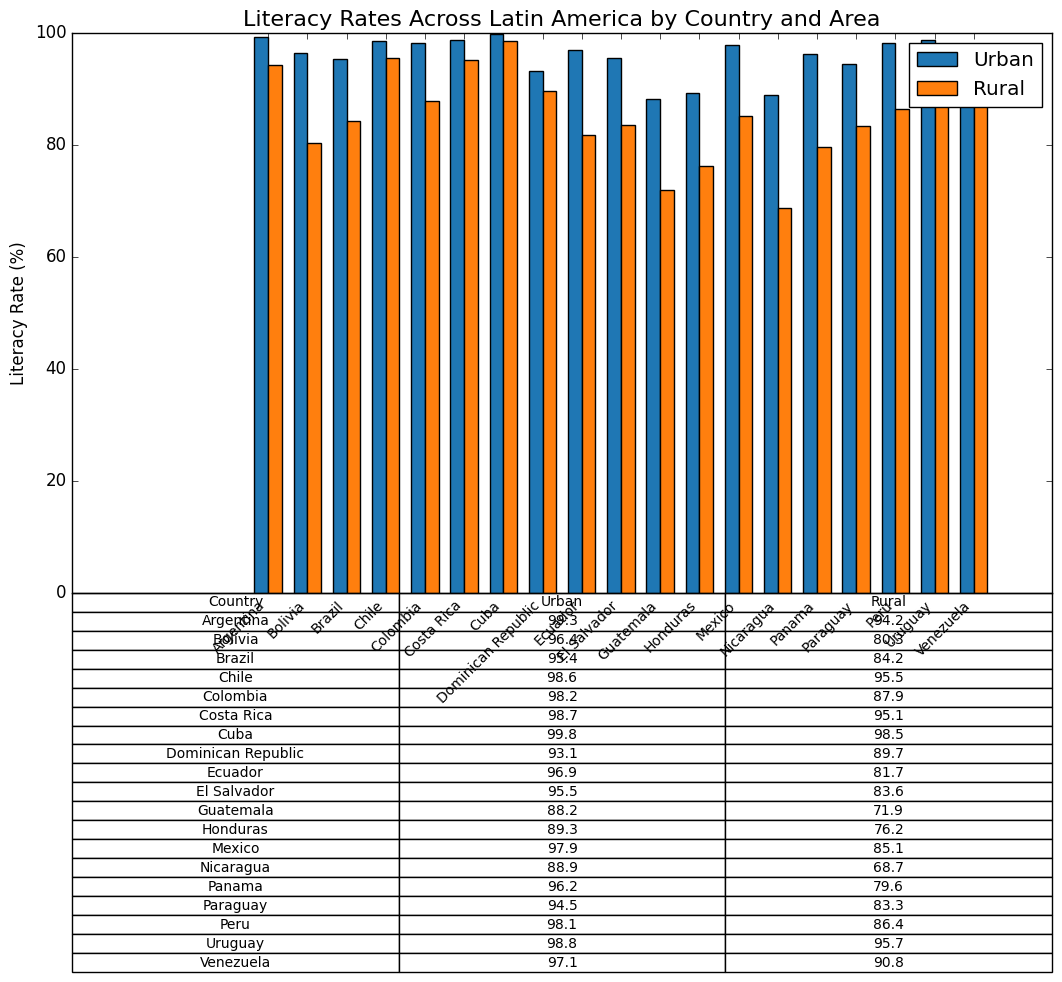What's the country with the highest rural literacy rate? Cuba has the highest rural literacy rate at 98.5%. This can be determined by looking at the values in the table under the "Rural" column or the height of the orange bars in the plot for rural areas.
Answer: Cuba Which country has a smaller gap between urban and rural literacy rates: Paraguay or Brazil? The gap is calculated by subtracting the rural literacy rate from the urban literacy rate for each country. For Paraguay, it's 94.5 - 83.3 = 11.2 percentage points. For Brazil, it's 95.4 - 84.2 = 11.2 percentage points. Thus, both countries have the same gap between urban and rural literacy rates.
Answer: Both have the same gap Which country has the largest difference in literacy rates between urban and rural areas? To find the largest difference, subtract the rural literacy rate from the urban literacy rate for each country and compare the results. The largest difference is for Guatemala: 88.2 (Urban) - 71.9 (Rural) = 16.3 percentage points.
Answer: Guatemala What is the average urban literacy rate across all the countries? To calculate the average urban literacy rate, sum the urban literacy rates and divide by the number of countries: (99.3 + 96.4 + 95.4 + 98.6 + 98.2 + 98.7 + 99.8 + 93.1 + 96.9 + 95.5 + 88.2 + 89.3 + 97.9 + 88.9 + 96.2 + 94.5 + 98.1 + 98.8 + 97.1) / 19 = 96.10%.
Answer: 96.10% Which two countries have the closest urban literacy rates? By comparing the urban literacy rates for all countries, the closest rates are for Colombia (98.2) and Peru (98.1), with a difference of 0.1 percentage points.
Answer: Colombia and Peru Which country's rural literacy rate is closest to 80%? Looking at the "Rural" column in the table, Bolivia has a rural literacy rate of 80.3%, which is the closest to 80%.
Answer: Bolivia What's the average rural literacy rate for countries where the urban literacy rate is greater than 98%? First, identify countries where the urban literacy rate is greater than 98%: Argentina, Chile, Colombia, Costa Rica, Cuba, Peru, Uruguay. Next, average their rural literacy rates: (94.2 + 95.5 + 87.9 + 95.1 + 98.5 + 86.4 + 95.7) / 7 = 93.33%.
Answer: 93.33% Which country has the lowest urban literacy rate? From the table, Nicaragua has the lowest urban literacy rate at 88.9%.
Answer: Nicaragua How much higher is the urban literacy rate compared to the rural literacy rate on average across all countries? Calculate the difference for each country, sum them up, and then get the average. Differences: (5.1 + 16.1 + 11.2 + 3.1 + 10.3 + 3.6 + 1.3 + 3.4 + 15.2 + 11.9 + 16.3 + 13.1 + 12.8 + 20.2 + 16.6 + 7.2 + 11.2 + 11.7 + 6.3). Sum = 186.7 / 19 = 9.83 percentage points.
Answer: 9.83 percentage points Which country shows the smallest difference between urban and rural literacy rates? By comparing the differences, Cuba has the smallest difference between urban (99.8%) and rural (98.5%) literacy rates, which is 1.3 percentage points.
Answer: Cuba 